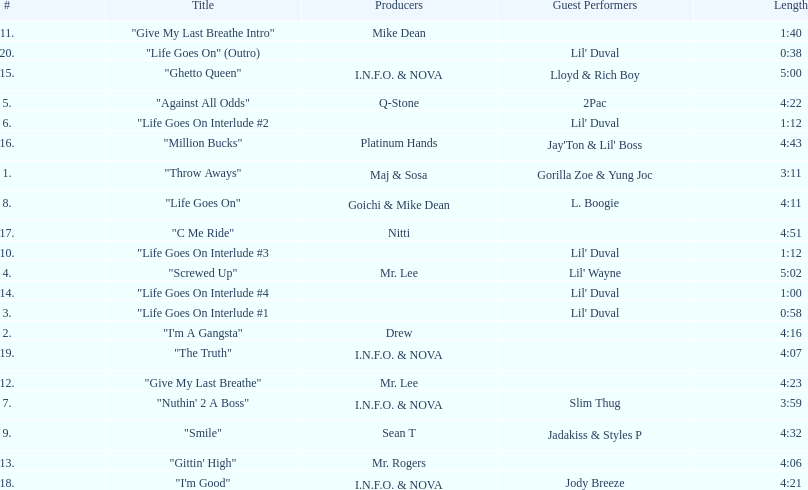What is the last track produced by mr. lee? "Give My Last Breathe". 